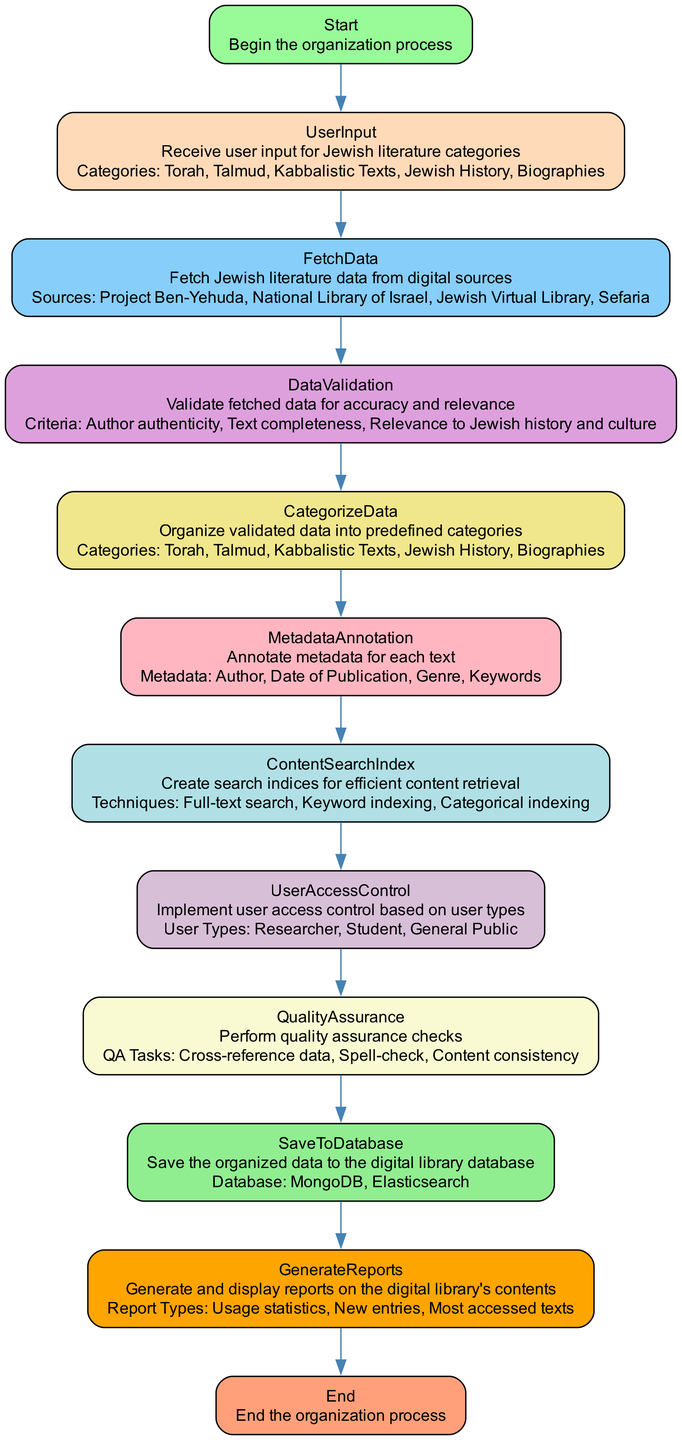What is the starting point of the flowchart? The flowchart begins with the "Start" node, which indicates the initiation of the organization process for the digital library of Jewish literature.
Answer: Start How many categories are there for user input? From the "UserInput" node, we see that the categories listed are Torah, Talmud, Kabbalistic Texts, Jewish History, and Biographies, totaling five categories.
Answer: Five What is the source for fetching data? The "FetchData" node indicates several sources including Project Ben-Yehuda, National Library of Israel, Jewish Virtual Library, and Sefaria. One of the sources is Project Ben-Yehuda.
Answer: Project Ben-Yehuda Which node follows DataValidation? Following the "DataValidation" process, the next step in the flowchart is "CategorizeData," indicating that validated data is organized into predefined categories.
Answer: CategorizeData What types of user access are implemented? The "UserAccessControl" node specifies three user types: Researcher, Student, and General Public, meaning these are the implemented access types in the system.
Answer: Researcher, Student, General Public What tasks are included in the quality assurance process? The "QualityAssurance" node details several tasks: Cross-reference data, Spell-check, and Content consistency, illustrating the checks performed for quality assurance.
Answer: Cross-reference data, Spell-check, Content consistency How is the data stored after organization? The "SaveToDatabase" node indicates that organized data is saved to databases, including MongoDB and Elasticsearch, showing how the system stores the processed digital library data.
Answer: MongoDB, Elasticsearch What type of reports are generated in the final step? In the "GenerateReports" node, it reveals the types of reports that are generated, such as Usage statistics, New entries, and Most accessed texts, indicating the analytics produced for the digital library.
Answer: Usage statistics, New entries, Most accessed texts What is the final node in the flowchart? The flowchart concludes with the "End" node, which signifies the completion of the organization process for the digital library of Jewish literature.
Answer: End 